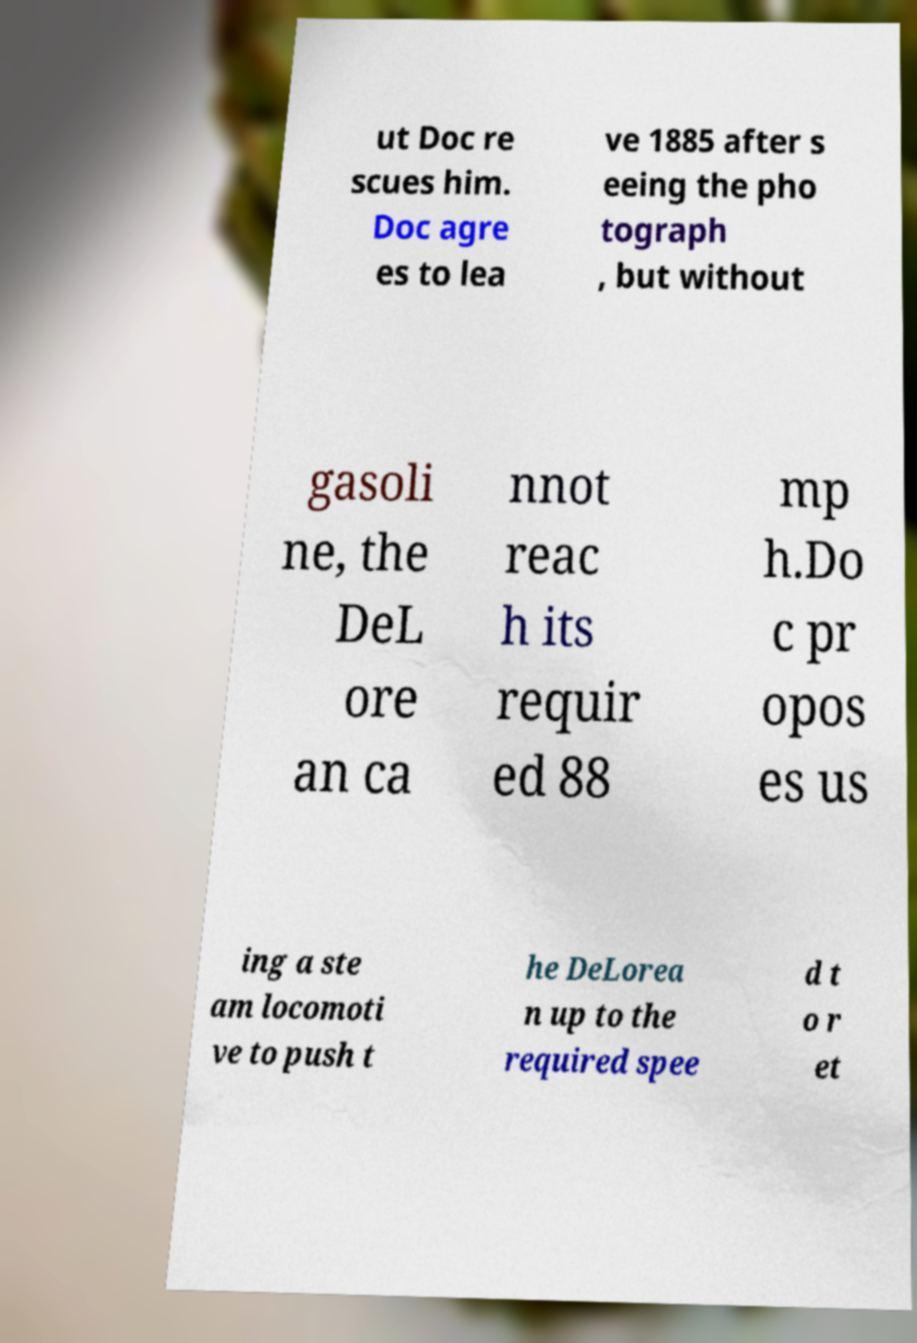Please identify and transcribe the text found in this image. ut Doc re scues him. Doc agre es to lea ve 1885 after s eeing the pho tograph , but without gasoli ne, the DeL ore an ca nnot reac h its requir ed 88 mp h.Do c pr opos es us ing a ste am locomoti ve to push t he DeLorea n up to the required spee d t o r et 